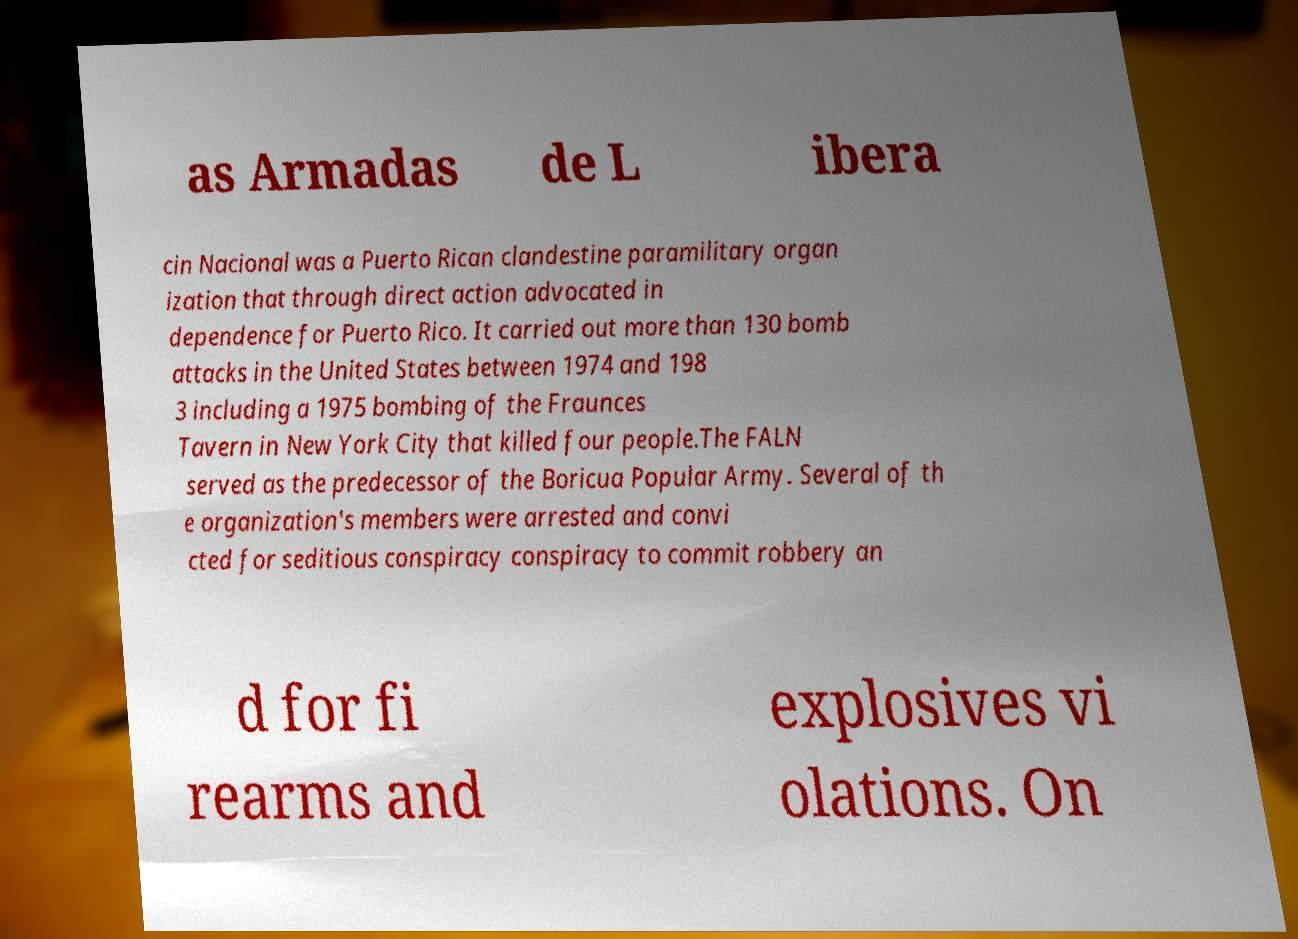There's text embedded in this image that I need extracted. Can you transcribe it verbatim? as Armadas de L ibera cin Nacional was a Puerto Rican clandestine paramilitary organ ization that through direct action advocated in dependence for Puerto Rico. It carried out more than 130 bomb attacks in the United States between 1974 and 198 3 including a 1975 bombing of the Fraunces Tavern in New York City that killed four people.The FALN served as the predecessor of the Boricua Popular Army. Several of th e organization's members were arrested and convi cted for seditious conspiracy conspiracy to commit robbery an d for fi rearms and explosives vi olations. On 